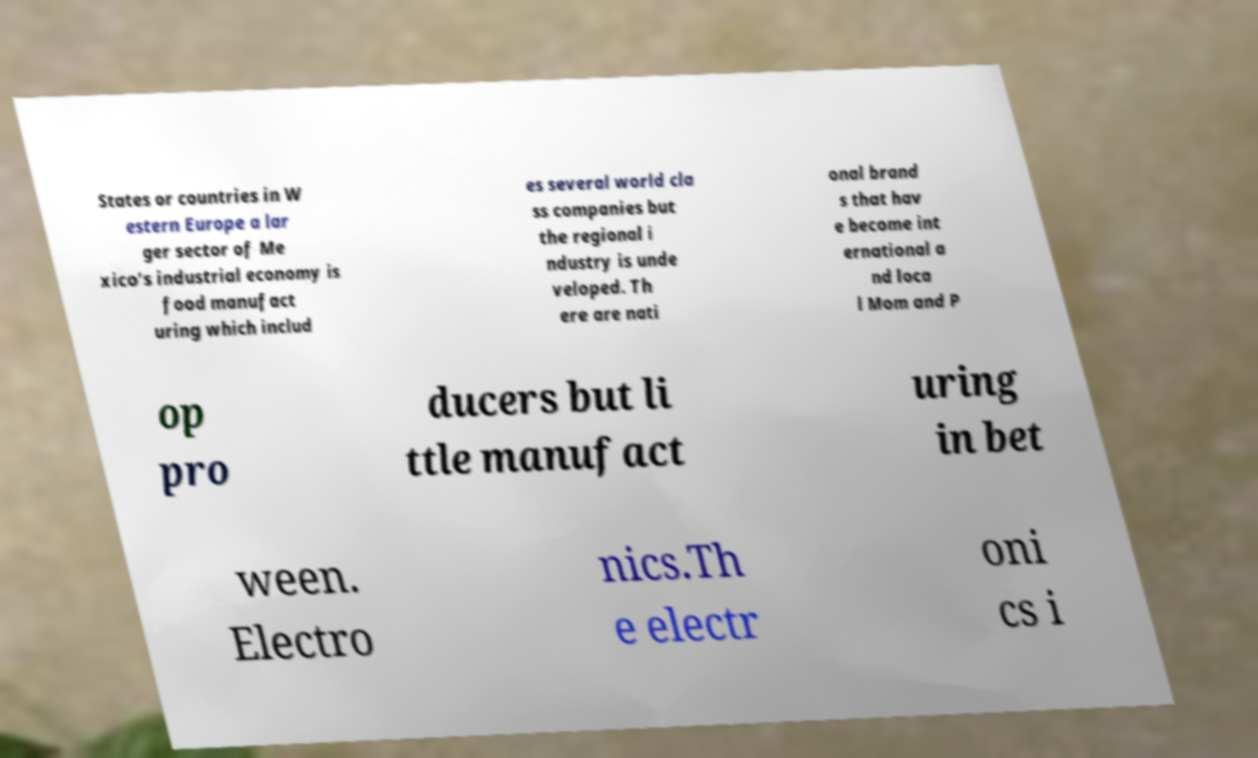For documentation purposes, I need the text within this image transcribed. Could you provide that? States or countries in W estern Europe a lar ger sector of Me xico's industrial economy is food manufact uring which includ es several world cla ss companies but the regional i ndustry is unde veloped. Th ere are nati onal brand s that hav e become int ernational a nd loca l Mom and P op pro ducers but li ttle manufact uring in bet ween. Electro nics.Th e electr oni cs i 